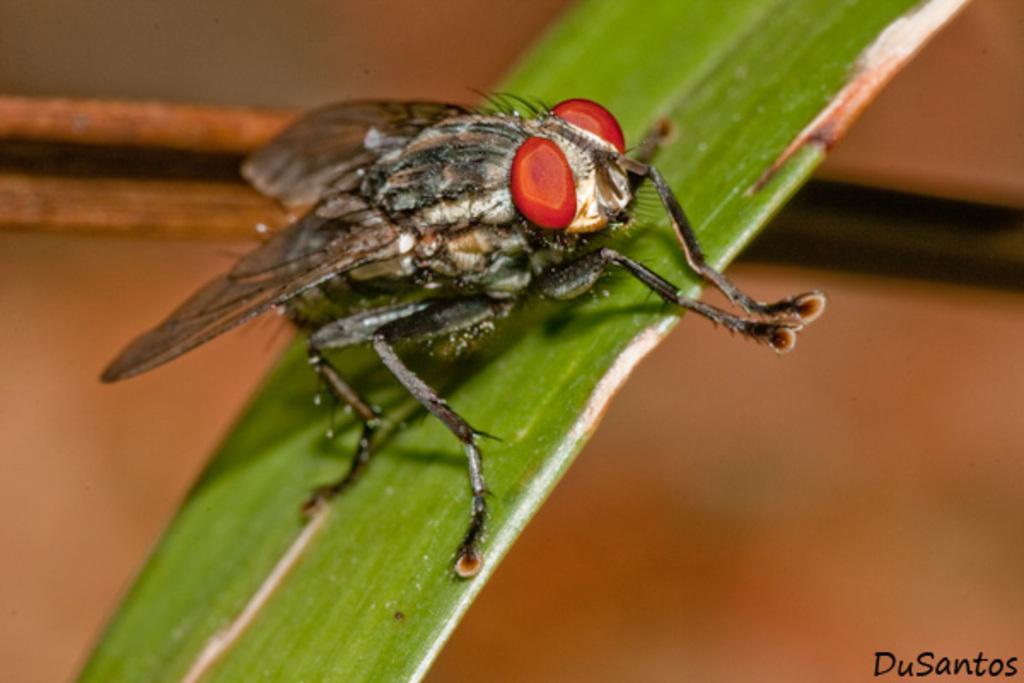Can you describe this image briefly? In the center of the image we can see a fly on the leaf. 